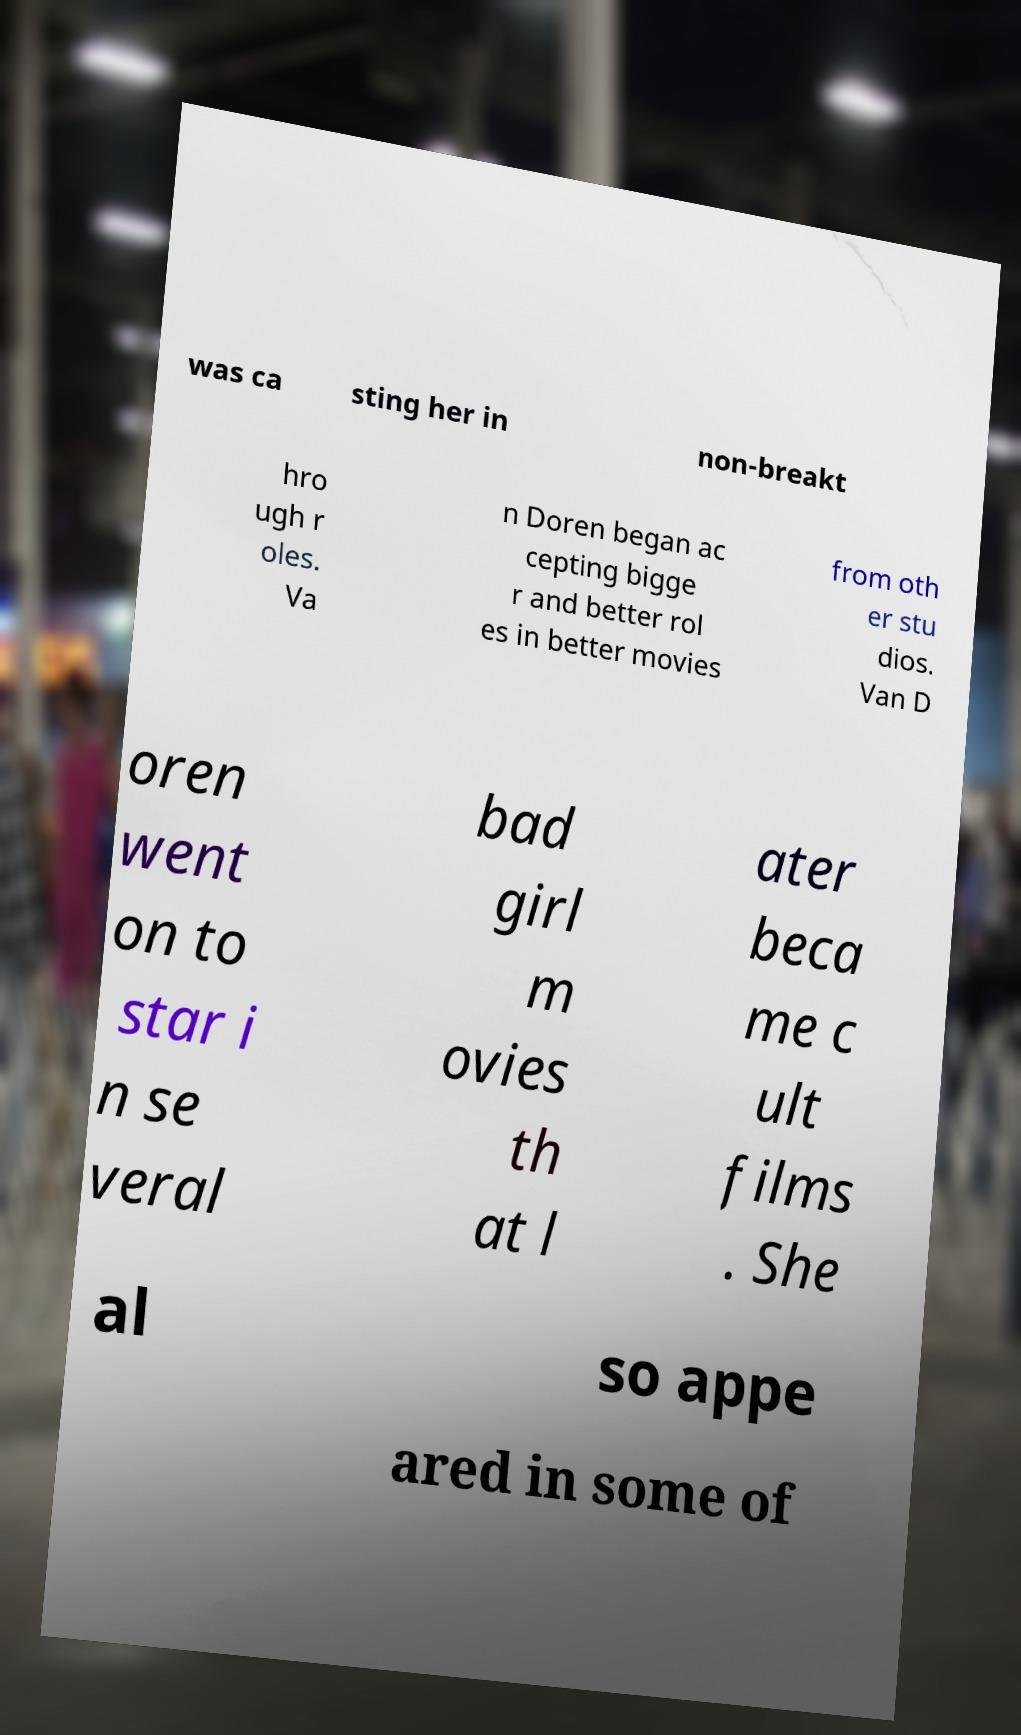Could you assist in decoding the text presented in this image and type it out clearly? was ca sting her in non-breakt hro ugh r oles. Va n Doren began ac cepting bigge r and better rol es in better movies from oth er stu dios. Van D oren went on to star i n se veral bad girl m ovies th at l ater beca me c ult films . She al so appe ared in some of 